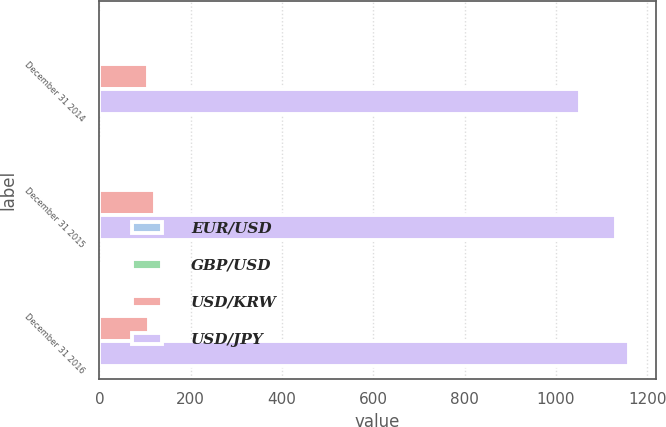Convert chart. <chart><loc_0><loc_0><loc_500><loc_500><stacked_bar_chart><ecel><fcel>December 31 2014<fcel>December 31 2015<fcel>December 31 2016<nl><fcel>EUR/USD<fcel>1.65<fcel>1.53<fcel>1.35<nl><fcel>GBP/USD<fcel>1.33<fcel>1.11<fcel>1.11<nl><fcel>USD/KRW<fcel>105.59<fcel>121.02<fcel>108.53<nl><fcel>USD/JPY<fcel>1052.71<fcel>1131.54<fcel>1160.7<nl></chart> 